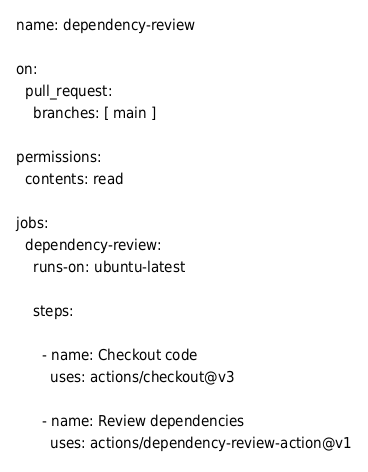<code> <loc_0><loc_0><loc_500><loc_500><_YAML_>name: dependency-review

on:
  pull_request:
    branches: [ main ]

permissions:
  contents: read

jobs:
  dependency-review:
    runs-on: ubuntu-latest

    steps:

      - name: Checkout code
        uses: actions/checkout@v3

      - name: Review dependencies
        uses: actions/dependency-review-action@v1
</code> 